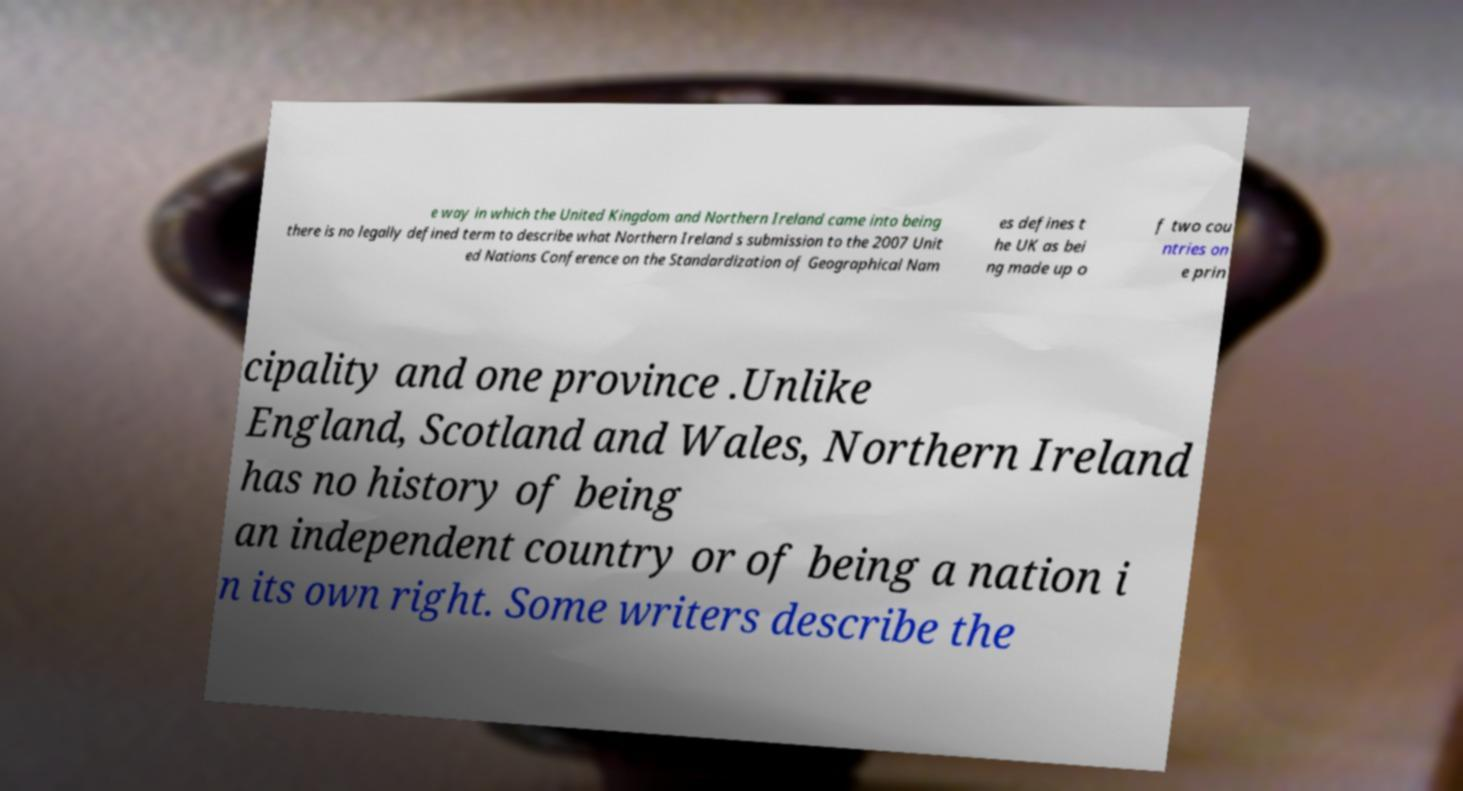For documentation purposes, I need the text within this image transcribed. Could you provide that? e way in which the United Kingdom and Northern Ireland came into being there is no legally defined term to describe what Northern Ireland s submission to the 2007 Unit ed Nations Conference on the Standardization of Geographical Nam es defines t he UK as bei ng made up o f two cou ntries on e prin cipality and one province .Unlike England, Scotland and Wales, Northern Ireland has no history of being an independent country or of being a nation i n its own right. Some writers describe the 